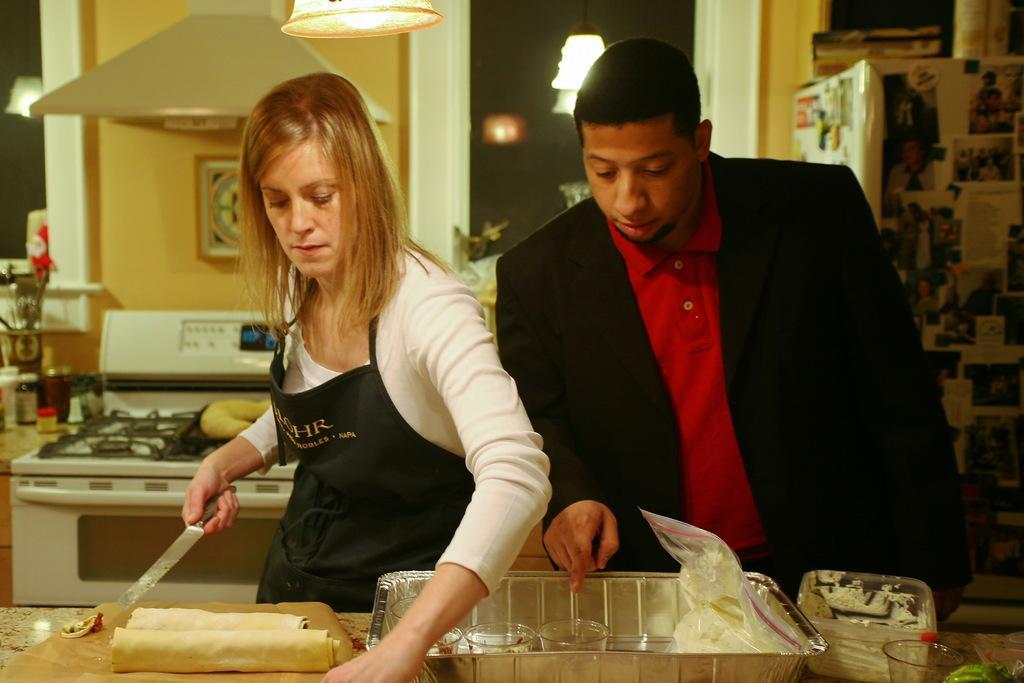Please provide a concise description of this image. As we can see in the image there is a wall, two people standing in the front, table, gas stove and lights. On table there is a tray, glasses and box. The man on the right side is wearing black color jacket and the woman is wearing white color dress. 